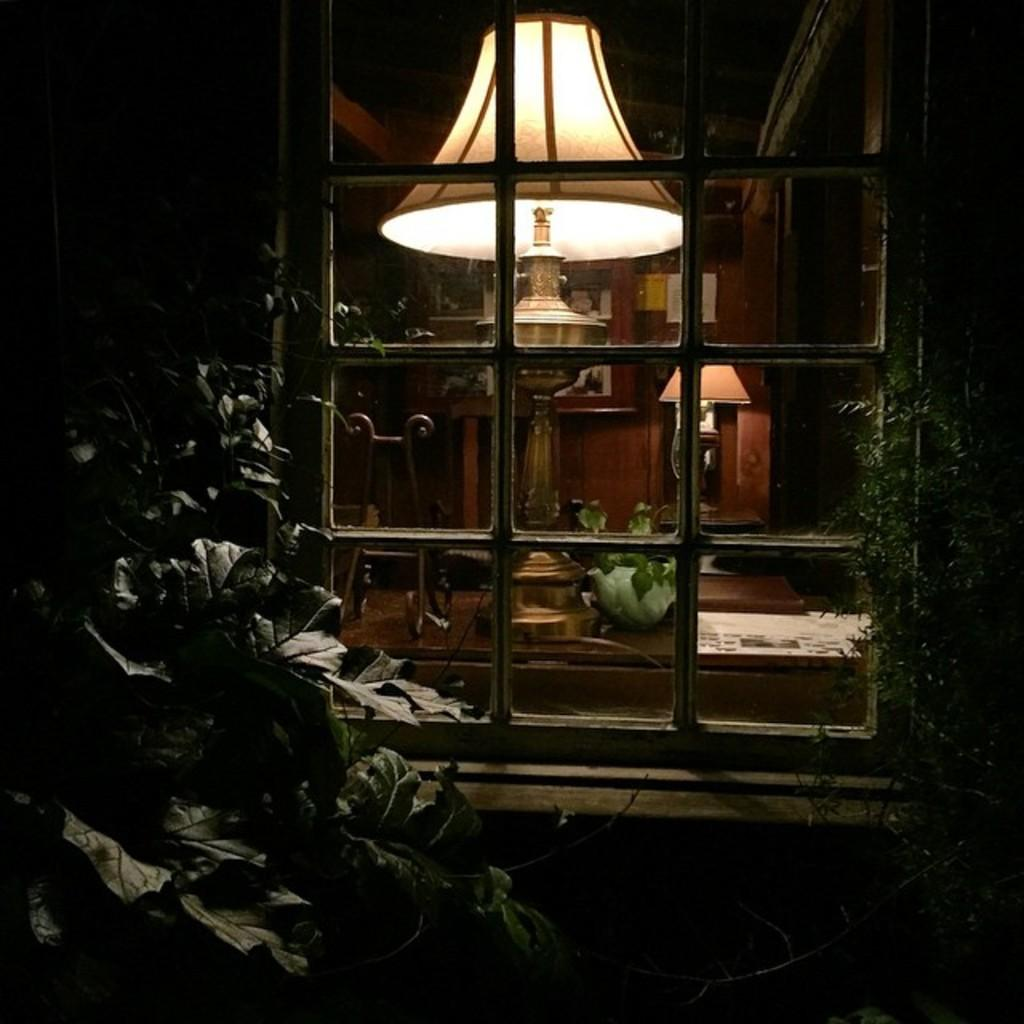What type of living organisms can be seen in the image? Plants are visible in the image. What architectural feature is present in the image? There is a window in the image. What type of furniture is in the image? There is a chair in the image. What objects are on a table in the image? There are items on a table in the image. What type of lighting is present in the image? There are lamps in the image. What type of decorative item is in the image? There is a frame in the image. What is attached to a wall in the image? Papers are attached to a wall in the image. How does the temper of the plants affect the growth of the insects in the image? There are no insects present in the image, and the temper of the plants cannot be determined from the image. 